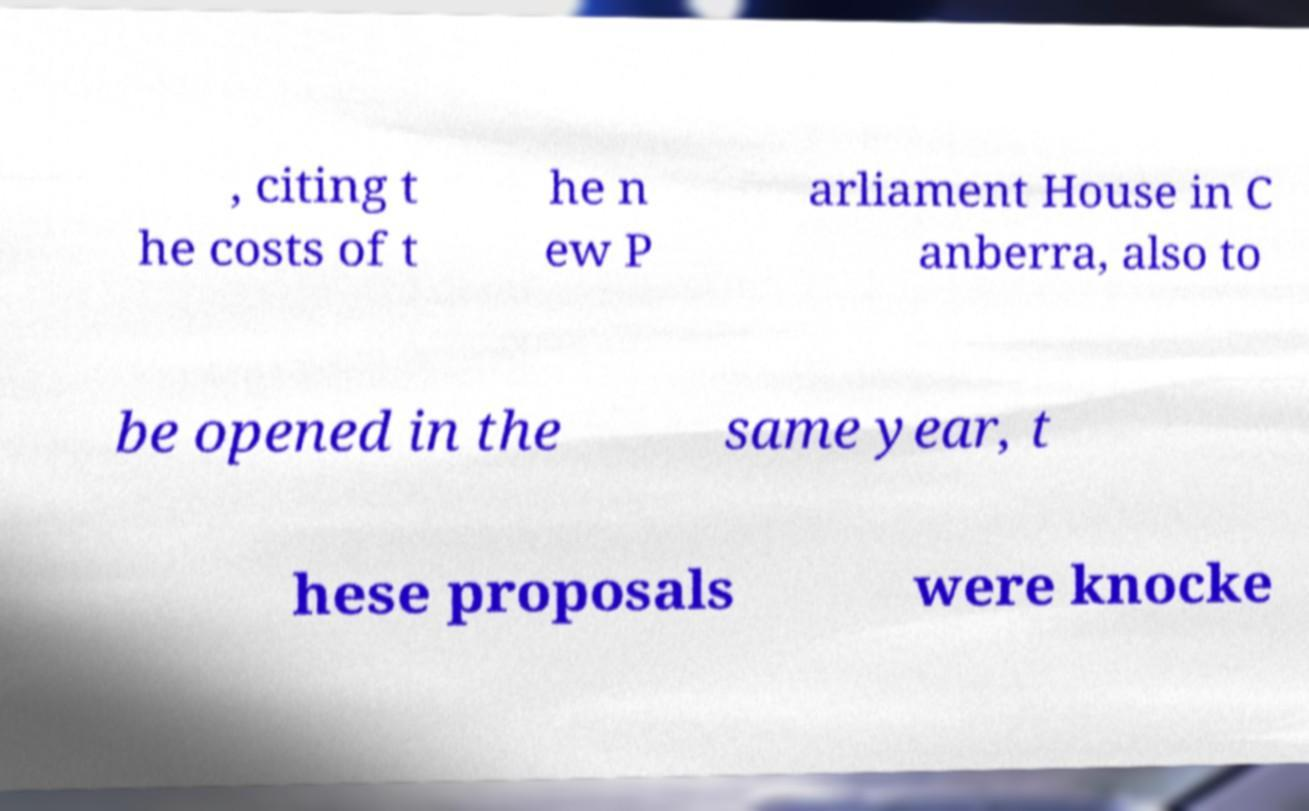Can you read and provide the text displayed in the image?This photo seems to have some interesting text. Can you extract and type it out for me? , citing t he costs of t he n ew P arliament House in C anberra, also to be opened in the same year, t hese proposals were knocke 